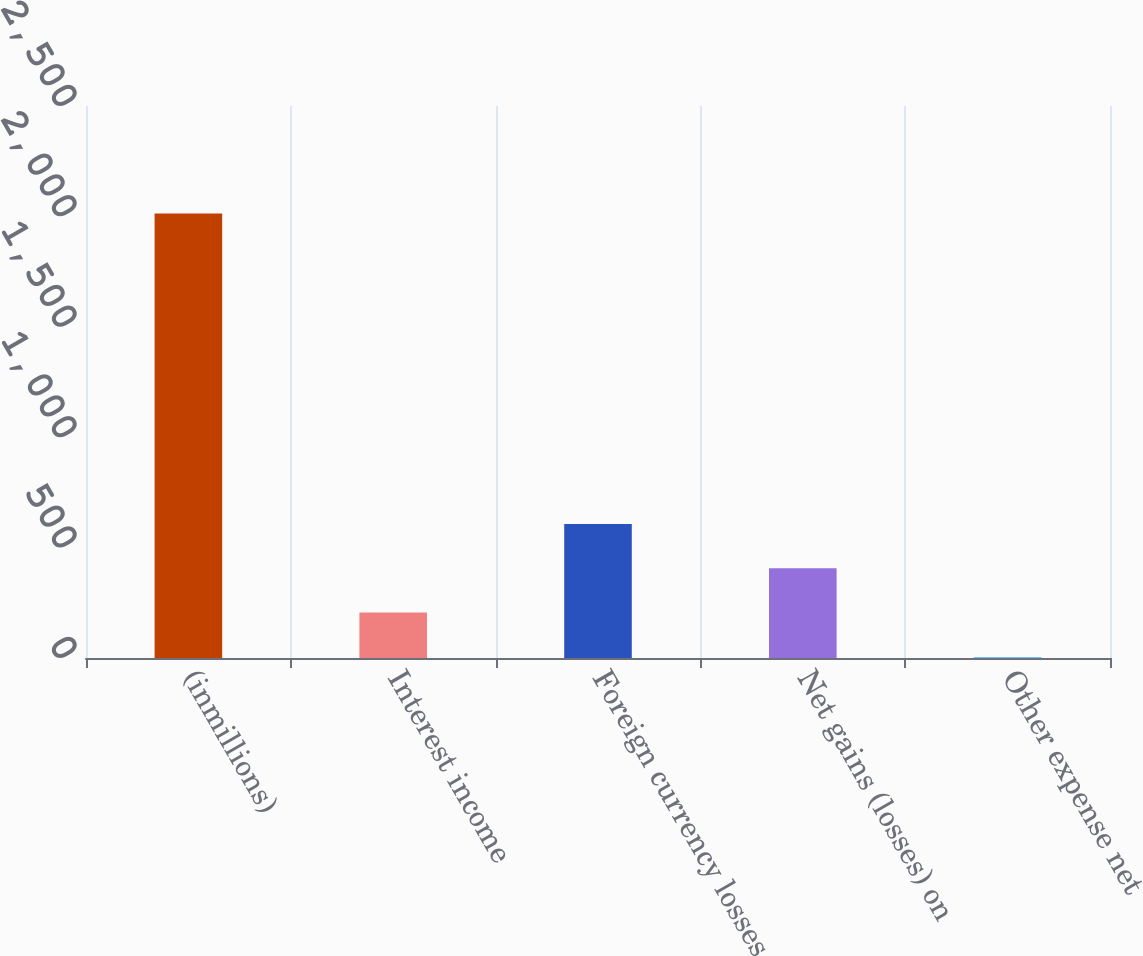Convert chart to OTSL. <chart><loc_0><loc_0><loc_500><loc_500><bar_chart><fcel>(inmillions)<fcel>Interest income<fcel>Foreign currency losses<fcel>Net gains (losses) on<fcel>Other expense net<nl><fcel>2013<fcel>205.8<fcel>607.4<fcel>406.6<fcel>5<nl></chart> 